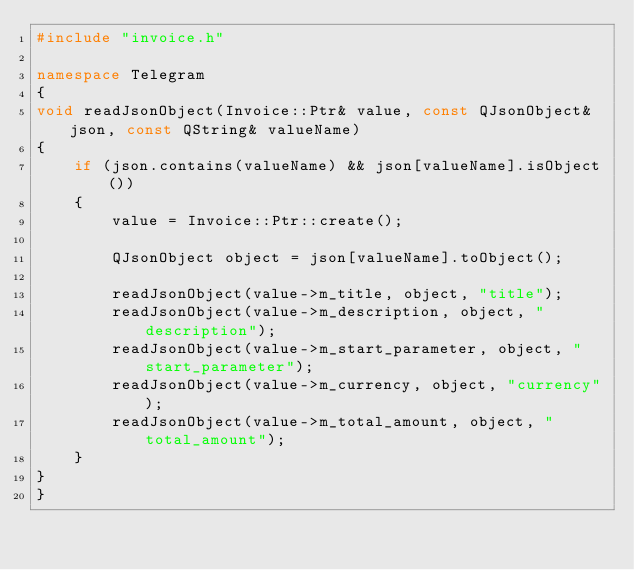Convert code to text. <code><loc_0><loc_0><loc_500><loc_500><_C++_>#include "invoice.h"

namespace Telegram
{
void readJsonObject(Invoice::Ptr& value, const QJsonObject& json, const QString& valueName)
{
    if (json.contains(valueName) && json[valueName].isObject())
    {
        value = Invoice::Ptr::create();

        QJsonObject object = json[valueName].toObject();

        readJsonObject(value->m_title, object, "title");
        readJsonObject(value->m_description, object, "description");
        readJsonObject(value->m_start_parameter, object, "start_parameter");
        readJsonObject(value->m_currency, object, "currency");
        readJsonObject(value->m_total_amount, object, "total_amount");
    }
}
}
</code> 